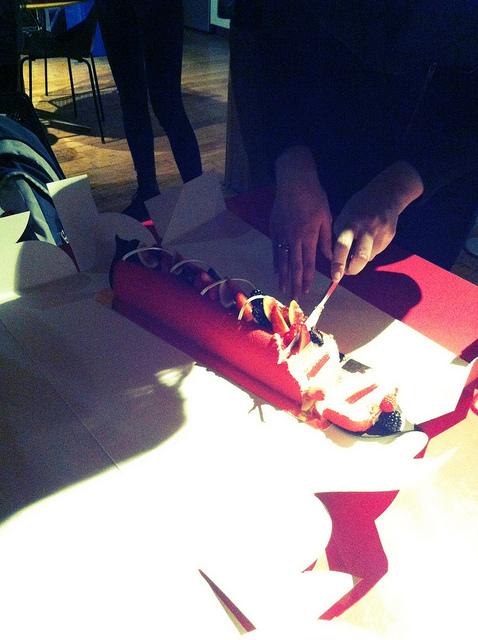What color is the person's shirt?
Short answer required. Black. Is it sunny?
Be succinct. Yes. What is taking place in this photo?
Keep it brief. Cutting food. 